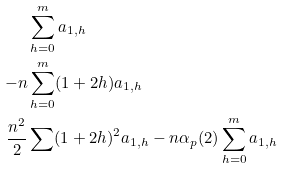<formula> <loc_0><loc_0><loc_500><loc_500>& \sum ^ { m } _ { h = 0 } a _ { 1 , h } \\ - n & \sum ^ { m } _ { h = 0 } ( 1 + 2 h ) a _ { 1 , h } \\ \frac { n ^ { 2 } } { 2 } & \sum ( 1 + 2 h ) ^ { 2 } a _ { 1 , h } - n \alpha _ { p } ( 2 ) \sum ^ { m } _ { h = 0 } a _ { 1 , h }</formula> 